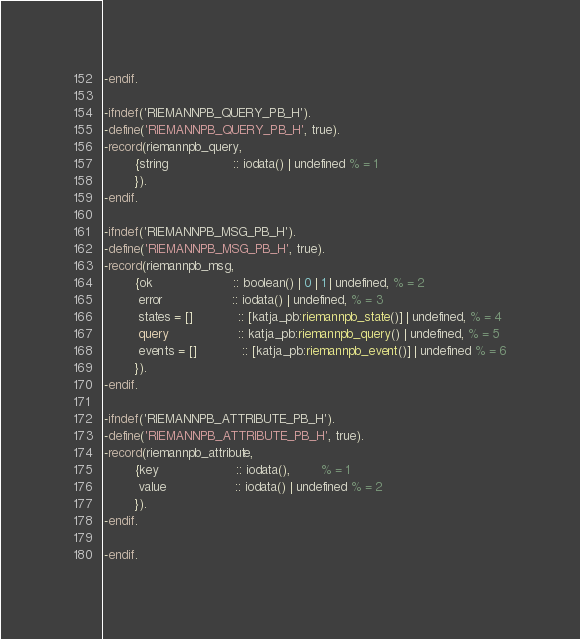<code> <loc_0><loc_0><loc_500><loc_500><_Erlang_>-endif.

-ifndef('RIEMANNPB_QUERY_PB_H').
-define('RIEMANNPB_QUERY_PB_H', true).
-record(riemannpb_query,
        {string                 :: iodata() | undefined % = 1
        }).
-endif.

-ifndef('RIEMANNPB_MSG_PB_H').
-define('RIEMANNPB_MSG_PB_H', true).
-record(riemannpb_msg,
        {ok                     :: boolean() | 0 | 1 | undefined, % = 2
         error                  :: iodata() | undefined, % = 3
         states = []            :: [katja_pb:riemannpb_state()] | undefined, % = 4
         query                  :: katja_pb:riemannpb_query() | undefined, % = 5
         events = []            :: [katja_pb:riemannpb_event()] | undefined % = 6
        }).
-endif.

-ifndef('RIEMANNPB_ATTRIBUTE_PB_H').
-define('RIEMANNPB_ATTRIBUTE_PB_H', true).
-record(riemannpb_attribute,
        {key                    :: iodata(),        % = 1
         value                  :: iodata() | undefined % = 2
        }).
-endif.

-endif.
</code> 